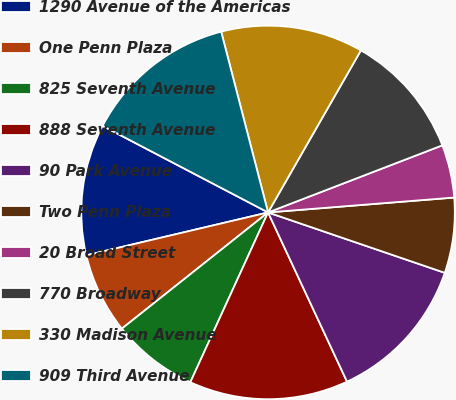Convert chart. <chart><loc_0><loc_0><loc_500><loc_500><pie_chart><fcel>1290 Avenue of the Americas<fcel>One Penn Plaza<fcel>825 Seventh Avenue<fcel>888 Seventh Avenue<fcel>90 Park Avenue<fcel>Two Penn Plaza<fcel>20 Broad Street<fcel>770 Broadway<fcel>330 Madison Avenue<fcel>909 Third Avenue<nl><fcel>11.36%<fcel>7.0%<fcel>7.48%<fcel>13.78%<fcel>12.81%<fcel>6.51%<fcel>4.58%<fcel>10.87%<fcel>12.32%<fcel>13.29%<nl></chart> 